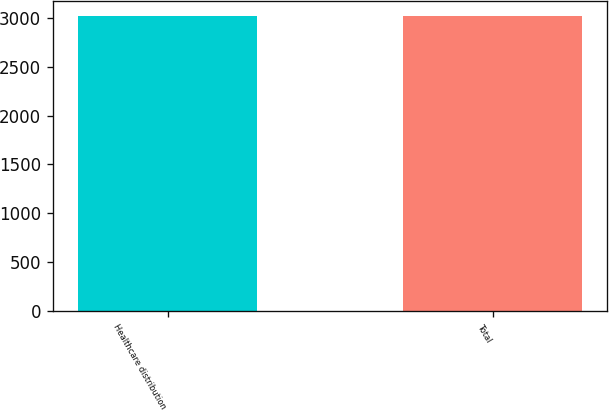Convert chart. <chart><loc_0><loc_0><loc_500><loc_500><bar_chart><fcel>Healthcare distribution<fcel>Total<nl><fcel>3020<fcel>3020.1<nl></chart> 